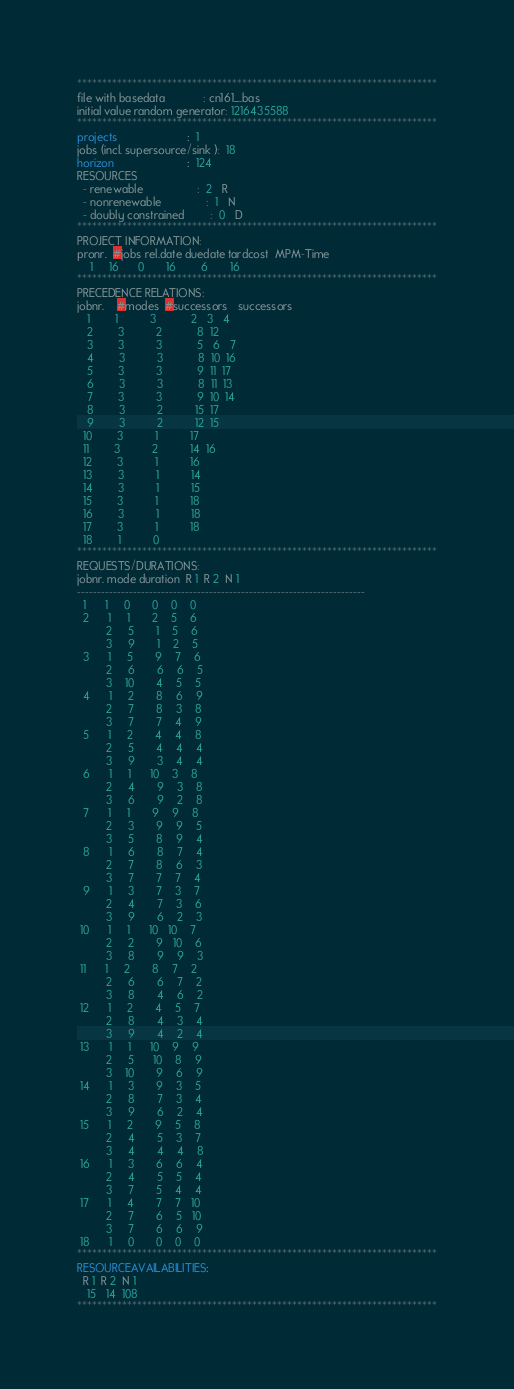Convert code to text. <code><loc_0><loc_0><loc_500><loc_500><_ObjectiveC_>************************************************************************
file with basedata            : cn161_.bas
initial value random generator: 1216435588
************************************************************************
projects                      :  1
jobs (incl. supersource/sink ):  18
horizon                       :  124
RESOURCES
  - renewable                 :  2   R
  - nonrenewable              :  1   N
  - doubly constrained        :  0   D
************************************************************************
PROJECT INFORMATION:
pronr.  #jobs rel.date duedate tardcost  MPM-Time
    1     16      0       16        6       16
************************************************************************
PRECEDENCE RELATIONS:
jobnr.    #modes  #successors   successors
   1        1          3           2   3   4
   2        3          2           8  12
   3        3          3           5   6   7
   4        3          3           8  10  16
   5        3          3           9  11  17
   6        3          3           8  11  13
   7        3          3           9  10  14
   8        3          2          15  17
   9        3          2          12  15
  10        3          1          17
  11        3          2          14  16
  12        3          1          16
  13        3          1          14
  14        3          1          15
  15        3          1          18
  16        3          1          18
  17        3          1          18
  18        1          0        
************************************************************************
REQUESTS/DURATIONS:
jobnr. mode duration  R 1  R 2  N 1
------------------------------------------------------------------------
  1      1     0       0    0    0
  2      1     1       2    5    6
         2     5       1    5    6
         3     9       1    2    5
  3      1     5       9    7    6
         2     6       6    6    5
         3    10       4    5    5
  4      1     2       8    6    9
         2     7       8    3    8
         3     7       7    4    9
  5      1     2       4    4    8
         2     5       4    4    4
         3     9       3    4    4
  6      1     1      10    3    8
         2     4       9    3    8
         3     6       9    2    8
  7      1     1       9    9    8
         2     3       9    9    5
         3     5       8    9    4
  8      1     6       8    7    4
         2     7       8    6    3
         3     7       7    7    4
  9      1     3       7    3    7
         2     4       7    3    6
         3     9       6    2    3
 10      1     1      10   10    7
         2     2       9   10    6
         3     8       9    9    3
 11      1     2       8    7    2
         2     6       6    7    2
         3     8       4    6    2
 12      1     2       4    5    7
         2     8       4    3    4
         3     9       4    2    4
 13      1     1      10    9    9
         2     5      10    8    9
         3    10       9    6    9
 14      1     3       9    3    5
         2     8       7    3    4
         3     9       6    2    4
 15      1     2       9    5    8
         2     4       5    3    7
         3     4       4    4    8
 16      1     3       6    6    4
         2     4       5    5    4
         3     7       5    4    4
 17      1     4       7    7   10
         2     7       6    5   10
         3     7       6    6    9
 18      1     0       0    0    0
************************************************************************
RESOURCEAVAILABILITIES:
  R 1  R 2  N 1
   15   14  108
************************************************************************
</code> 